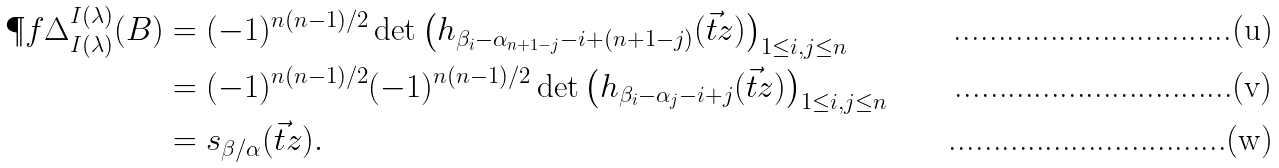Convert formula to latex. <formula><loc_0><loc_0><loc_500><loc_500>\P f \Delta ^ { I ( \lambda ) } _ { I ( \lambda ) } ( B ) & = ( - 1 ) ^ { n ( n - 1 ) / 2 } \det \left ( h _ { \beta _ { i } - \alpha _ { n + 1 - j } - i + ( n + 1 - j ) } ( \vec { t } z ) \right ) _ { 1 \leq i , j \leq n } \\ & = ( - 1 ) ^ { n ( n - 1 ) / 2 } ( - 1 ) ^ { n ( n - 1 ) / 2 } \det \left ( h _ { \beta _ { i } - \alpha _ { j } - i + j } ( \vec { t } z ) \right ) _ { 1 \leq i , j \leq n } \\ & = s _ { \beta / \alpha } ( \vec { t } z ) .</formula> 